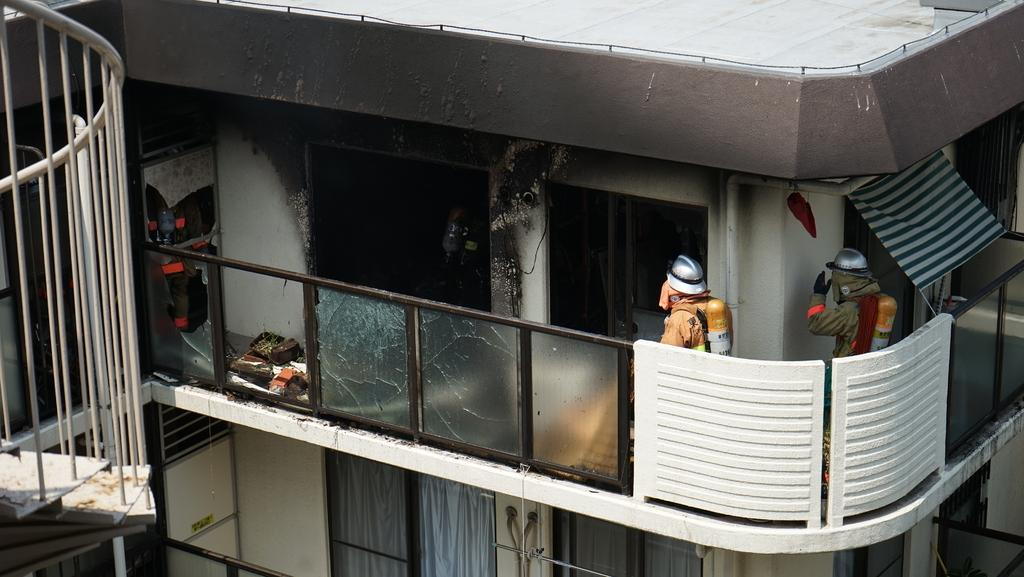What is happening in the center of the image? There is a person entering a building in the center of the image. What can be seen on the left side of the image? There are stairs on the left side of the image. What is located on the right side of the image? There is a cloth and a door on the right side of the image, as well as a wall. What type of surprise is the doll holding in the image? There is no doll present in the image, so it is not possible to determine what, if any, surprise it might be holding. 